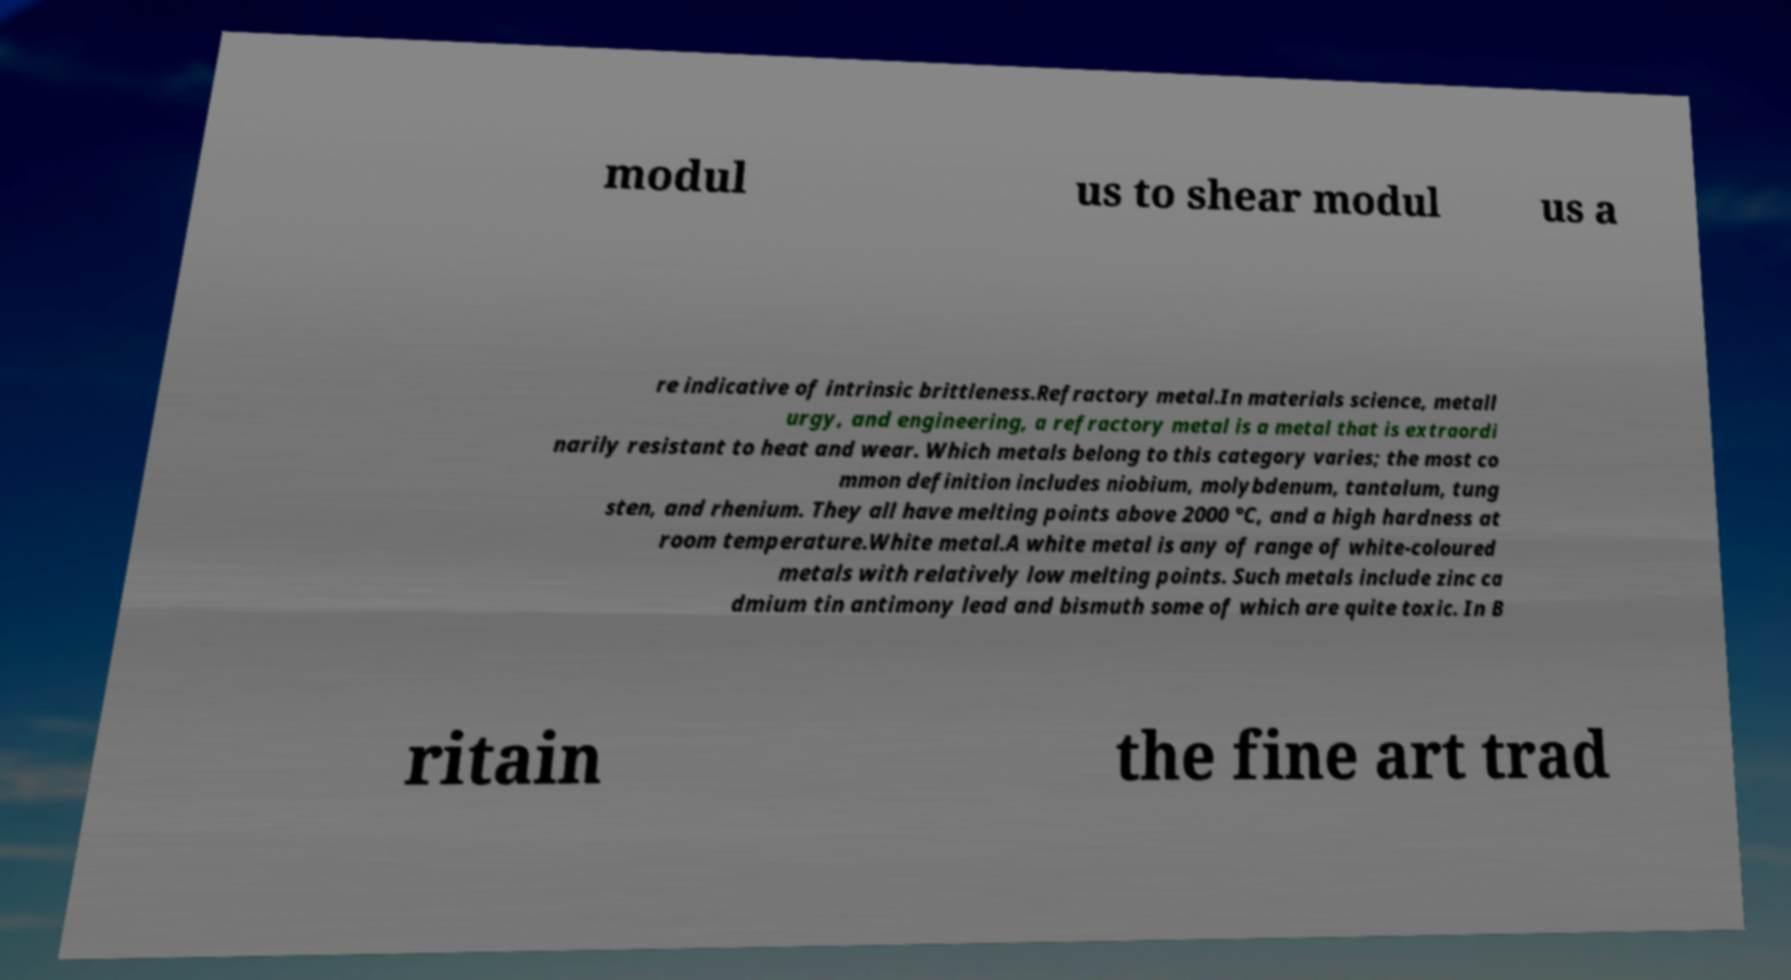There's text embedded in this image that I need extracted. Can you transcribe it verbatim? modul us to shear modul us a re indicative of intrinsic brittleness.Refractory metal.In materials science, metall urgy, and engineering, a refractory metal is a metal that is extraordi narily resistant to heat and wear. Which metals belong to this category varies; the most co mmon definition includes niobium, molybdenum, tantalum, tung sten, and rhenium. They all have melting points above 2000 °C, and a high hardness at room temperature.White metal.A white metal is any of range of white-coloured metals with relatively low melting points. Such metals include zinc ca dmium tin antimony lead and bismuth some of which are quite toxic. In B ritain the fine art trad 